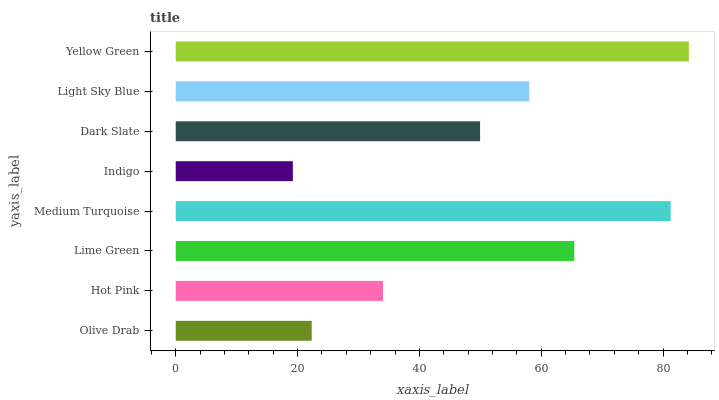Is Indigo the minimum?
Answer yes or no. Yes. Is Yellow Green the maximum?
Answer yes or no. Yes. Is Hot Pink the minimum?
Answer yes or no. No. Is Hot Pink the maximum?
Answer yes or no. No. Is Hot Pink greater than Olive Drab?
Answer yes or no. Yes. Is Olive Drab less than Hot Pink?
Answer yes or no. Yes. Is Olive Drab greater than Hot Pink?
Answer yes or no. No. Is Hot Pink less than Olive Drab?
Answer yes or no. No. Is Light Sky Blue the high median?
Answer yes or no. Yes. Is Dark Slate the low median?
Answer yes or no. Yes. Is Indigo the high median?
Answer yes or no. No. Is Lime Green the low median?
Answer yes or no. No. 